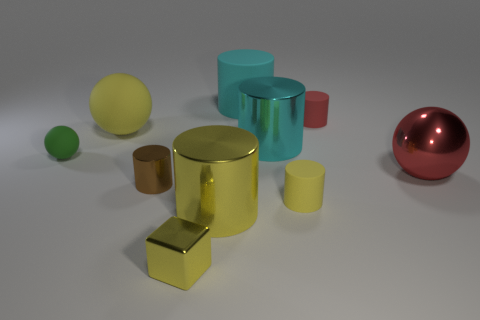What is the shape of the big yellow thing that is the same material as the red cylinder?
Give a very brief answer. Sphere. Are there fewer big yellow cylinders to the left of the big yellow shiny object than small green balls?
Your answer should be compact. Yes. What is the color of the tiny matte cylinder that is behind the yellow sphere?
Provide a short and direct response. Red. There is a big cylinder that is the same color as the block; what is it made of?
Give a very brief answer. Metal. Are there any big cyan matte things of the same shape as the brown object?
Make the answer very short. Yes. What number of green things have the same shape as the small yellow matte object?
Your answer should be very brief. 0. Is the shiny ball the same color as the big matte sphere?
Provide a succinct answer. No. Is the number of blue spheres less than the number of big spheres?
Provide a short and direct response. Yes. There is a large cylinder that is to the right of the cyan matte cylinder; what is it made of?
Keep it short and to the point. Metal. What is the material of the cube that is the same size as the green sphere?
Your answer should be compact. Metal. 